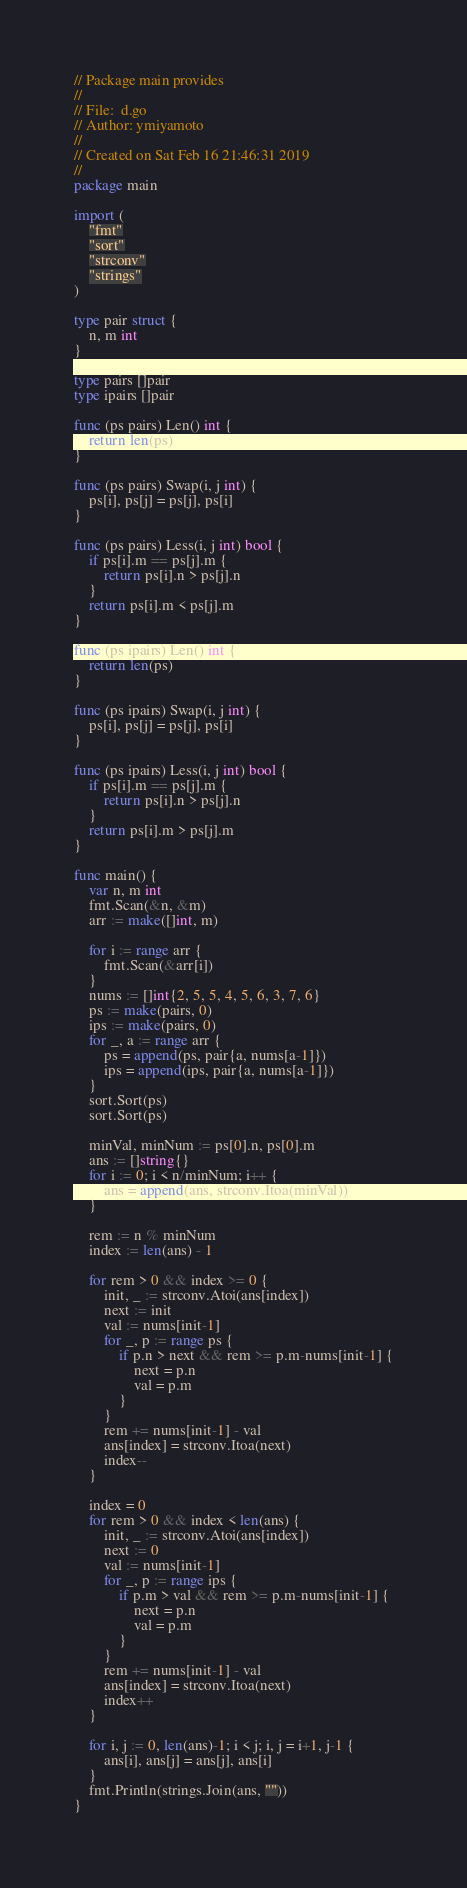Convert code to text. <code><loc_0><loc_0><loc_500><loc_500><_Go_>// Package main provides
//
// File:  d.go
// Author: ymiyamoto
//
// Created on Sat Feb 16 21:46:31 2019
//
package main

import (
	"fmt"
	"sort"
	"strconv"
	"strings"
)

type pair struct {
	n, m int
}

type pairs []pair
type ipairs []pair

func (ps pairs) Len() int {
	return len(ps)
}

func (ps pairs) Swap(i, j int) {
	ps[i], ps[j] = ps[j], ps[i]
}

func (ps pairs) Less(i, j int) bool {
	if ps[i].m == ps[j].m {
		return ps[i].n > ps[j].n
	}
	return ps[i].m < ps[j].m
}

func (ps ipairs) Len() int {
	return len(ps)
}

func (ps ipairs) Swap(i, j int) {
	ps[i], ps[j] = ps[j], ps[i]
}

func (ps ipairs) Less(i, j int) bool {
	if ps[i].m == ps[j].m {
		return ps[i].n > ps[j].n
	}
	return ps[i].m > ps[j].m
}

func main() {
	var n, m int
	fmt.Scan(&n, &m)
	arr := make([]int, m)

	for i := range arr {
		fmt.Scan(&arr[i])
	}
	nums := []int{2, 5, 5, 4, 5, 6, 3, 7, 6}
	ps := make(pairs, 0)
	ips := make(pairs, 0)
	for _, a := range arr {
		ps = append(ps, pair{a, nums[a-1]})
		ips = append(ips, pair{a, nums[a-1]})
	}
	sort.Sort(ps)
	sort.Sort(ps)

	minVal, minNum := ps[0].n, ps[0].m
	ans := []string{}
	for i := 0; i < n/minNum; i++ {
		ans = append(ans, strconv.Itoa(minVal))
	}

	rem := n % minNum
	index := len(ans) - 1

	for rem > 0 && index >= 0 {
		init, _ := strconv.Atoi(ans[index])
		next := init
		val := nums[init-1]
		for _, p := range ps {
			if p.n > next && rem >= p.m-nums[init-1] {
				next = p.n
				val = p.m
			}
		}
		rem += nums[init-1] - val
		ans[index] = strconv.Itoa(next)
		index--
	}

	index = 0
	for rem > 0 && index < len(ans) {
		init, _ := strconv.Atoi(ans[index])
		next := 0
		val := nums[init-1]
		for _, p := range ips {
			if p.m > val && rem >= p.m-nums[init-1] {
				next = p.n
				val = p.m
			}
		}
		rem += nums[init-1] - val
		ans[index] = strconv.Itoa(next)
		index++
	}

	for i, j := 0, len(ans)-1; i < j; i, j = i+1, j-1 {
		ans[i], ans[j] = ans[j], ans[i]
	}
	fmt.Println(strings.Join(ans, ""))
}
</code> 